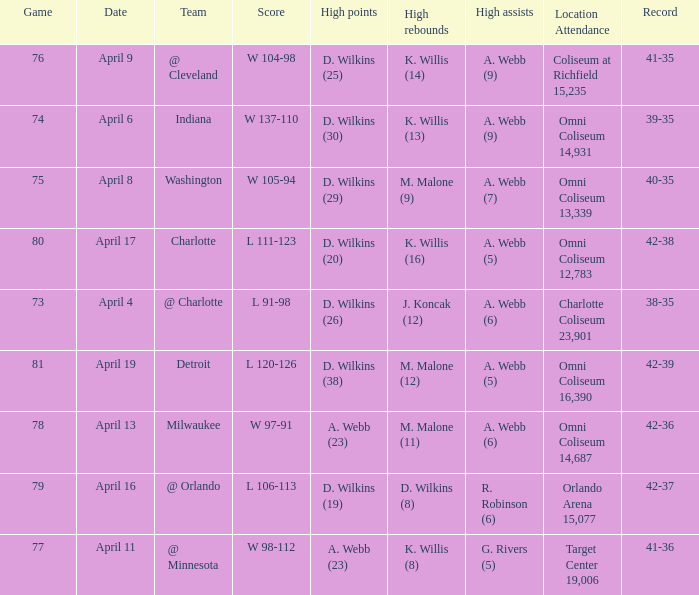How many people had the high points when a. webb (7) had the high assists? 1.0. 